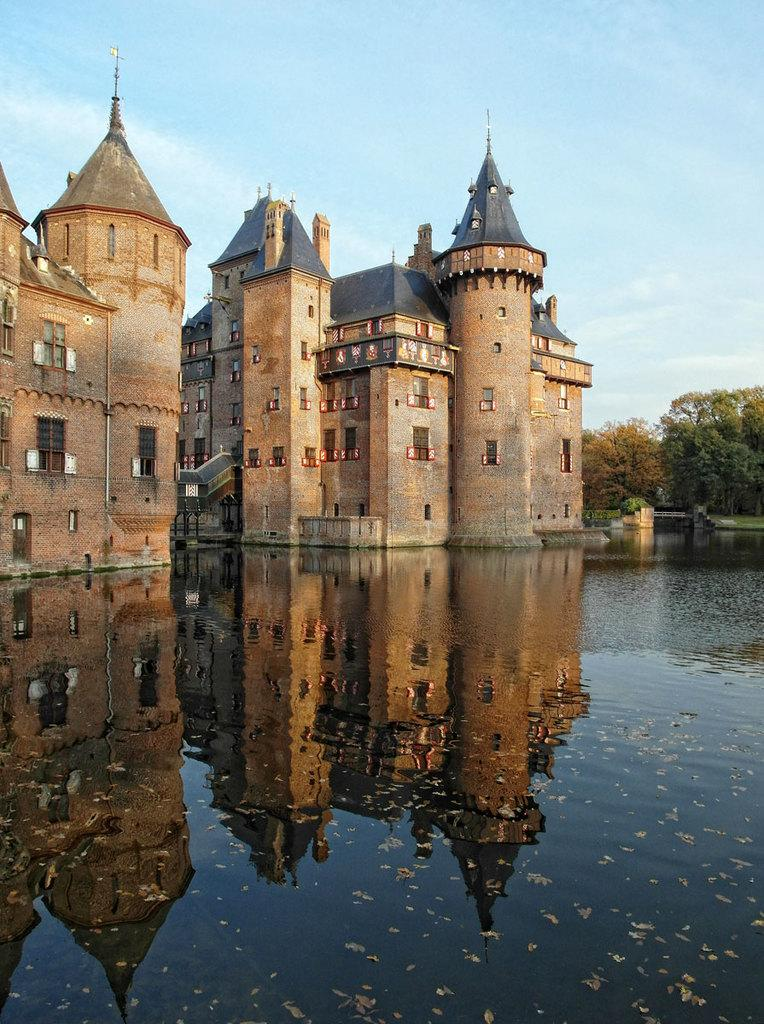What type of structures can be seen in the image? There are buildings in the image. What is visible at the bottom of the image? There is water visible at the bottom of the image. What type of vegetation is on the right side of the image? There are trees on the right side of the image. What is visible at the top of the image? The sky is visible at the top of the image. Can you see any bees flying around the buildings in the image? There are no bees visible in the image. Are there any dinosaurs present in the image? There are no dinosaurs present in the image. 